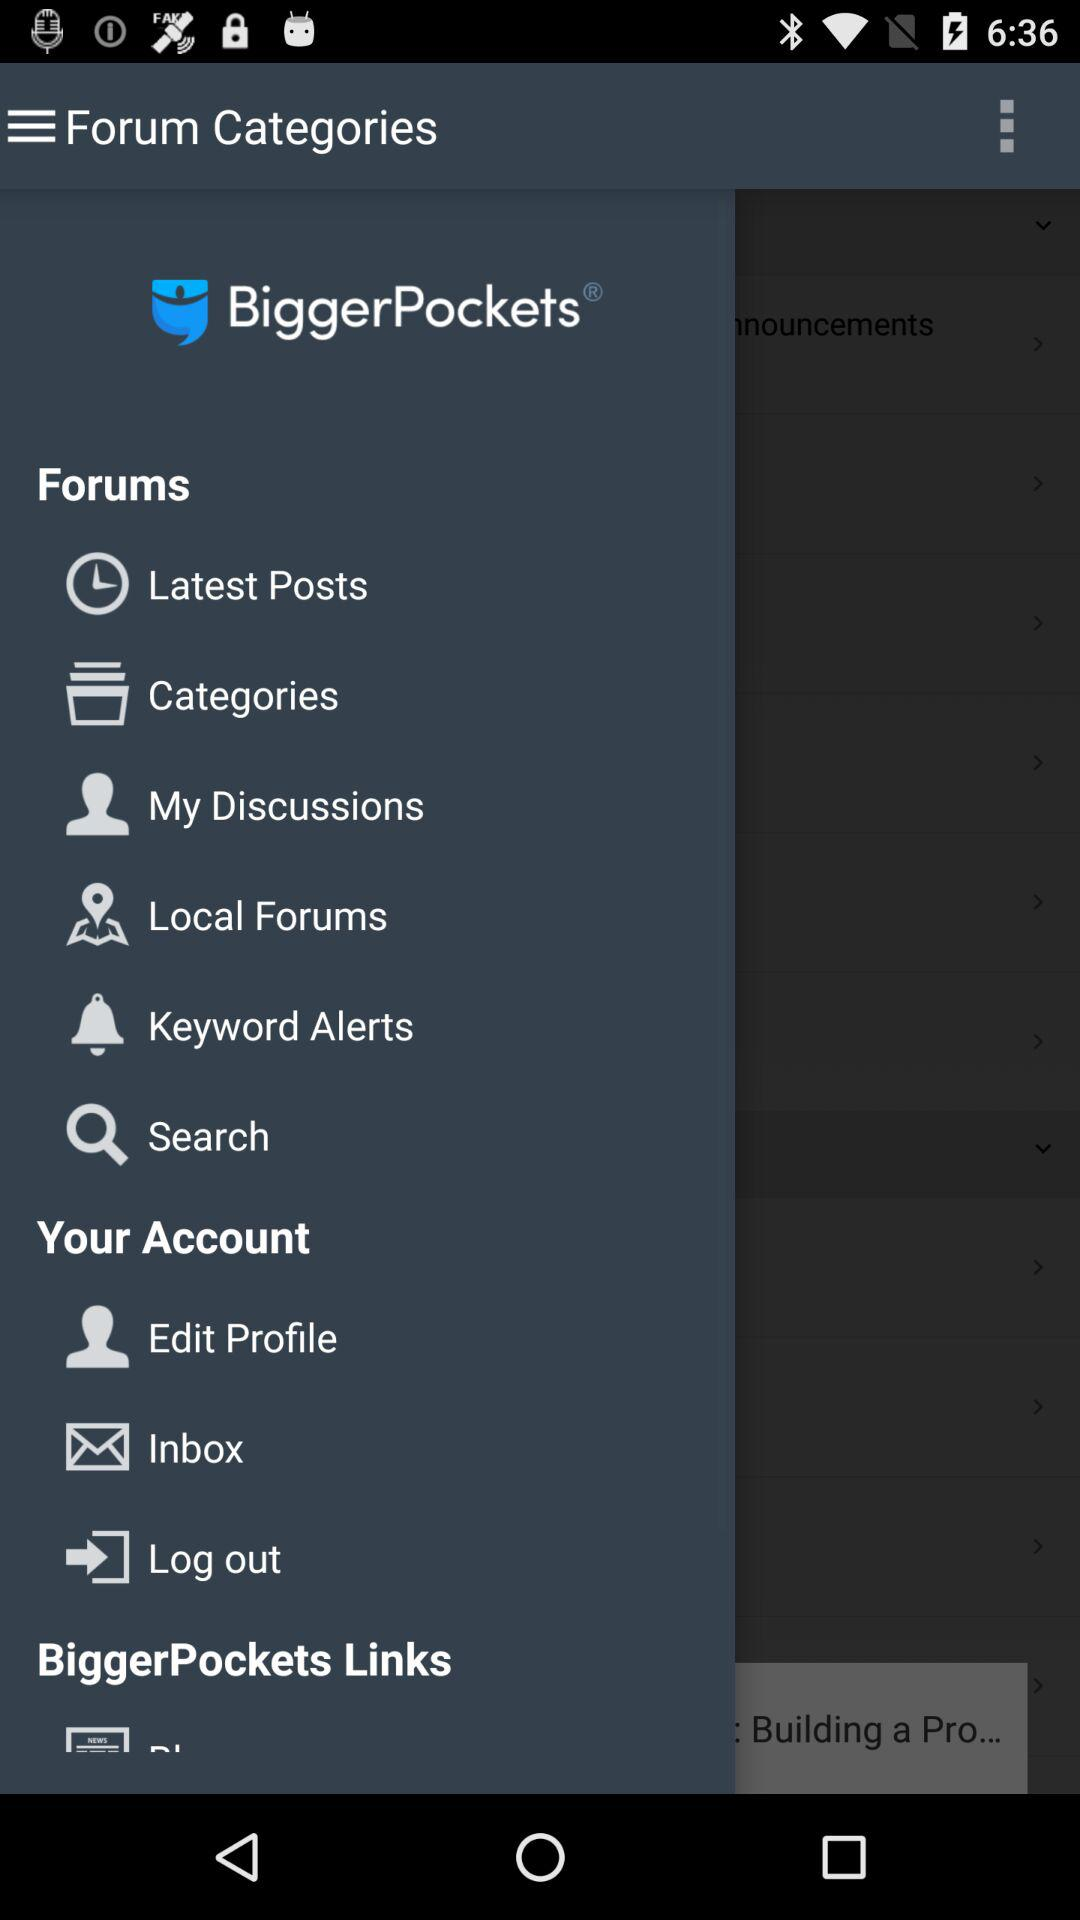What is the application name? The application name is "BiggerPockets". 